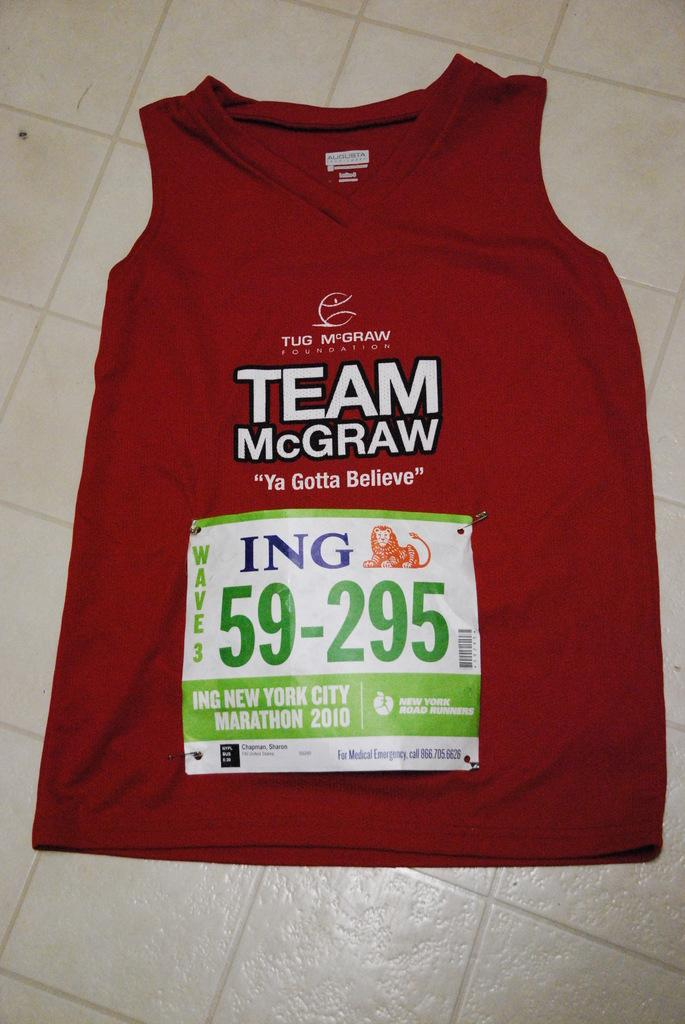<image>
Describe the image concisely. A red Team McGraw shirt on the floor. 